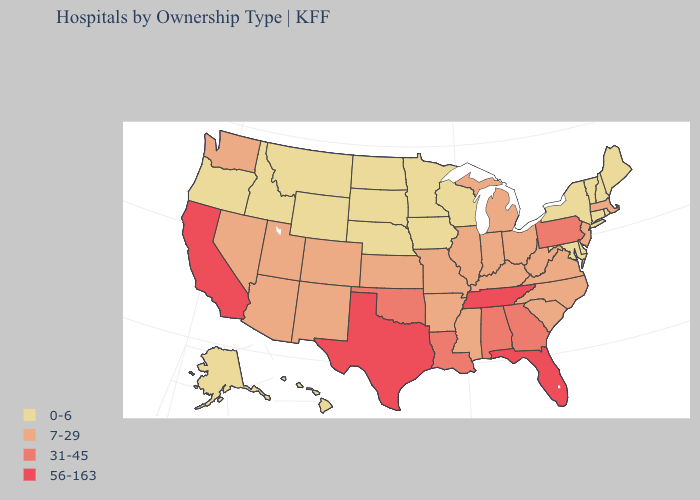Does Idaho have the highest value in the West?
Answer briefly. No. What is the value of Arkansas?
Answer briefly. 7-29. Which states hav the highest value in the MidWest?
Write a very short answer. Illinois, Indiana, Kansas, Michigan, Missouri, Ohio. Name the states that have a value in the range 0-6?
Keep it brief. Alaska, Connecticut, Delaware, Hawaii, Idaho, Iowa, Maine, Maryland, Minnesota, Montana, Nebraska, New Hampshire, New York, North Dakota, Oregon, Rhode Island, South Dakota, Vermont, Wisconsin, Wyoming. What is the highest value in the USA?
Quick response, please. 56-163. Which states have the lowest value in the West?
Answer briefly. Alaska, Hawaii, Idaho, Montana, Oregon, Wyoming. Which states hav the highest value in the Northeast?
Write a very short answer. Pennsylvania. Does Pennsylvania have the highest value in the Northeast?
Quick response, please. Yes. Name the states that have a value in the range 31-45?
Concise answer only. Alabama, Georgia, Louisiana, Oklahoma, Pennsylvania. How many symbols are there in the legend?
Give a very brief answer. 4. What is the value of Nebraska?
Answer briefly. 0-6. What is the value of Mississippi?
Keep it brief. 7-29. Name the states that have a value in the range 7-29?
Short answer required. Arizona, Arkansas, Colorado, Illinois, Indiana, Kansas, Kentucky, Massachusetts, Michigan, Mississippi, Missouri, Nevada, New Jersey, New Mexico, North Carolina, Ohio, South Carolina, Utah, Virginia, Washington, West Virginia. Does Delaware have the same value as Oklahoma?
Keep it brief. No. 